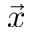<formula> <loc_0><loc_0><loc_500><loc_500>\vec { x }</formula> 